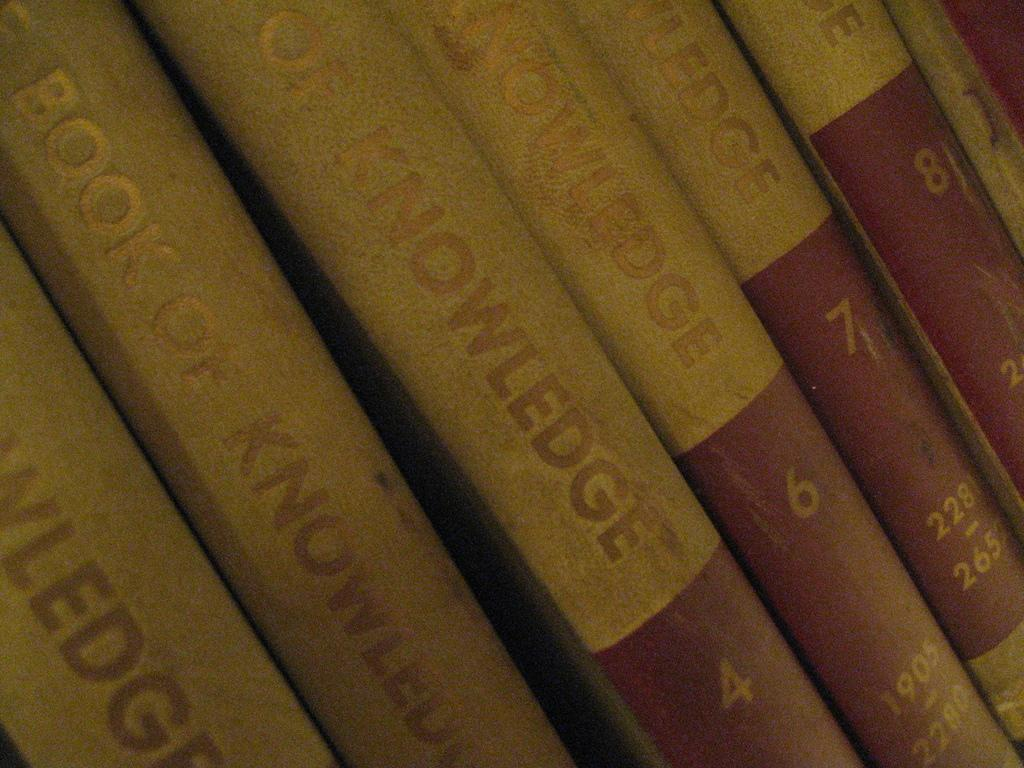<image>
Render a clear and concise summary of the photo. A collection of books titled Book of Knowledge. 